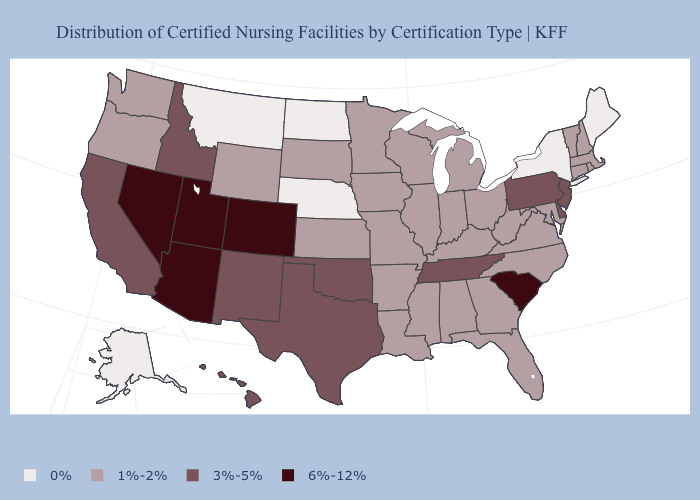Which states have the lowest value in the MidWest?
Keep it brief. Nebraska, North Dakota. Is the legend a continuous bar?
Give a very brief answer. No. Which states have the highest value in the USA?
Answer briefly. Arizona, Colorado, Nevada, South Carolina, Utah. What is the value of Maine?
Quick response, please. 0%. Does Connecticut have a higher value than New York?
Answer briefly. Yes. Name the states that have a value in the range 1%-2%?
Keep it brief. Alabama, Arkansas, Connecticut, Florida, Georgia, Illinois, Indiana, Iowa, Kansas, Kentucky, Louisiana, Maryland, Massachusetts, Michigan, Minnesota, Mississippi, Missouri, New Hampshire, North Carolina, Ohio, Oregon, Rhode Island, South Dakota, Vermont, Virginia, Washington, West Virginia, Wisconsin, Wyoming. What is the value of North Carolina?
Answer briefly. 1%-2%. Name the states that have a value in the range 0%?
Give a very brief answer. Alaska, Maine, Montana, Nebraska, New York, North Dakota. What is the value of Indiana?
Quick response, please. 1%-2%. Among the states that border Oklahoma , does Kansas have the lowest value?
Keep it brief. Yes. Does the first symbol in the legend represent the smallest category?
Keep it brief. Yes. Does Michigan have a higher value than New York?
Answer briefly. Yes. Name the states that have a value in the range 1%-2%?
Concise answer only. Alabama, Arkansas, Connecticut, Florida, Georgia, Illinois, Indiana, Iowa, Kansas, Kentucky, Louisiana, Maryland, Massachusetts, Michigan, Minnesota, Mississippi, Missouri, New Hampshire, North Carolina, Ohio, Oregon, Rhode Island, South Dakota, Vermont, Virginia, Washington, West Virginia, Wisconsin, Wyoming. What is the value of Alabama?
Be succinct. 1%-2%. 